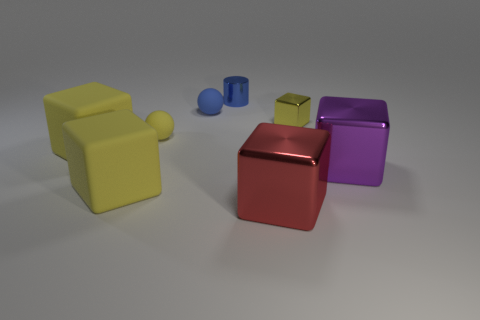There is a thing that is the same color as the metallic cylinder; what is it made of?
Offer a very short reply. Rubber. Does the ball in front of the tiny yellow shiny cube have the same color as the large cube that is behind the big purple cube?
Your answer should be very brief. Yes. What is the shape of the small yellow thing left of the small thing that is right of the shiny thing in front of the purple cube?
Offer a very short reply. Sphere. The other shiny object that is the same size as the purple object is what shape?
Ensure brevity in your answer.  Cube. There is a tiny yellow object that is right of the shiny block in front of the purple object; what number of red shiny cubes are on the left side of it?
Your answer should be compact. 1. Are there more big purple objects that are on the right side of the purple object than tiny cubes that are to the left of the blue cylinder?
Provide a short and direct response. No. How many things are either big cubes that are on the right side of the metallic cylinder or blocks behind the large red block?
Your answer should be very brief. 5. What is the yellow object on the right side of the tiny object behind the small blue thing that is in front of the tiny blue cylinder made of?
Your response must be concise. Metal. There is a tiny matte ball that is behind the small cube; is it the same color as the small cylinder?
Provide a short and direct response. Yes. What is the material of the cube that is both behind the big purple metallic block and on the left side of the big red thing?
Make the answer very short. Rubber. 